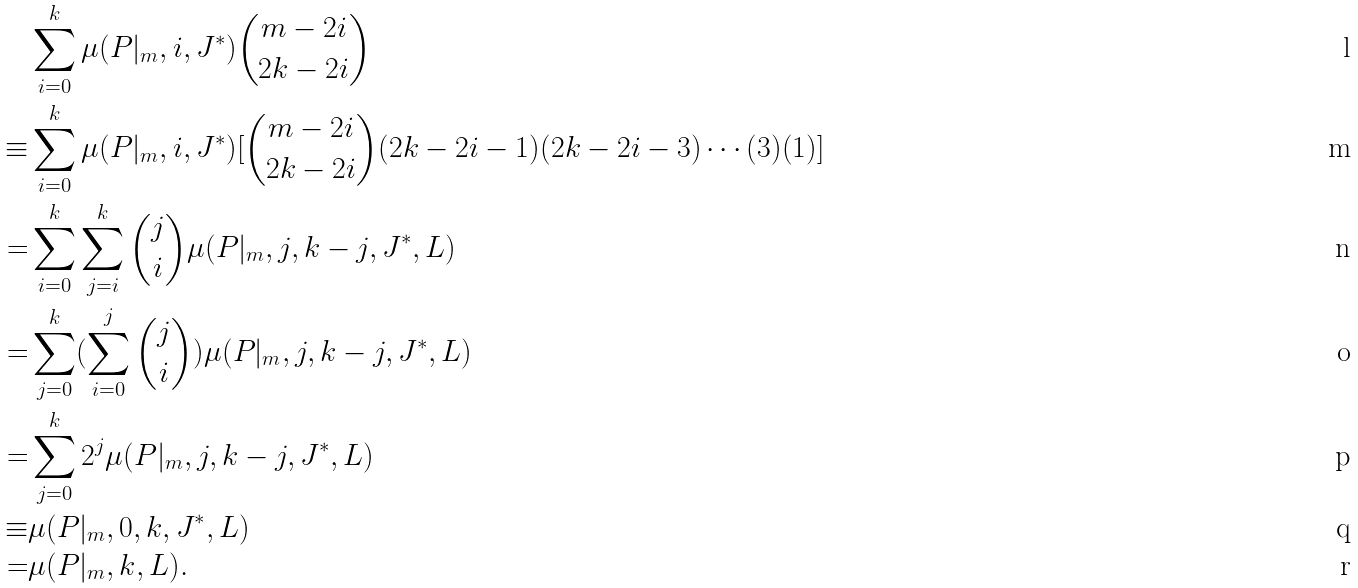Convert formula to latex. <formula><loc_0><loc_0><loc_500><loc_500>& \sum _ { i = 0 } ^ { k } \mu ( P | _ { m } , i , J ^ { \ast } ) \binom { m - 2 i } { 2 k - 2 i } \\ \equiv & \sum _ { i = 0 } ^ { k } \mu ( P | _ { m } , i , J ^ { \ast } ) [ \binom { m - 2 i } { 2 k - 2 i } ( 2 k - 2 i - 1 ) ( 2 k - 2 i - 3 ) \cdots ( 3 ) ( 1 ) ] \\ = & \sum _ { i = 0 } ^ { k } \sum _ { j = i } ^ { k } \binom { j } { i } \mu ( P | _ { m } , j , k - j , J ^ { \ast } , L ) \\ = & \sum _ { j = 0 } ^ { k } ( \sum _ { i = 0 } ^ { j } \binom { j } { i } ) \mu ( P | _ { m } , j , k - j , J ^ { \ast } , L ) \\ = & \sum _ { j = 0 } ^ { k } 2 ^ { j } \mu ( P | _ { m } , j , k - j , J ^ { \ast } , L ) \\ \equiv & \mu ( P | _ { m } , 0 , k , J ^ { \ast } , L ) \\ = & \mu ( P | _ { m } , k , L ) .</formula> 